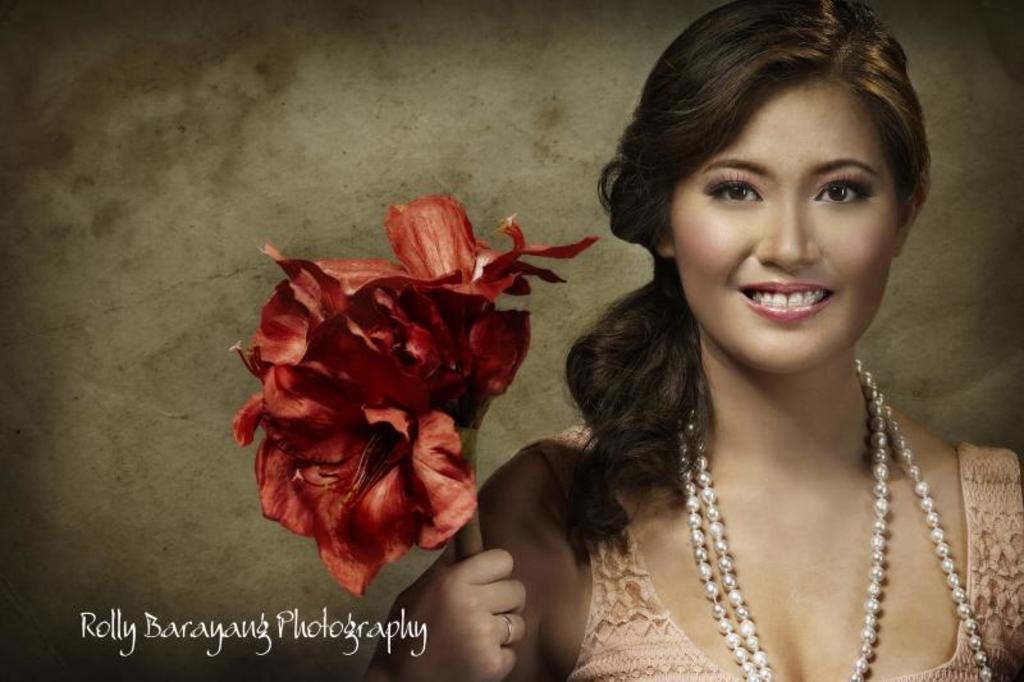Please provide a concise description of this image. In this image I can see a woman is holding the red color flower, she wore pearls chain, at the bottom there is the water mark. 